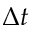Convert formula to latex. <formula><loc_0><loc_0><loc_500><loc_500>\Delta t</formula> 